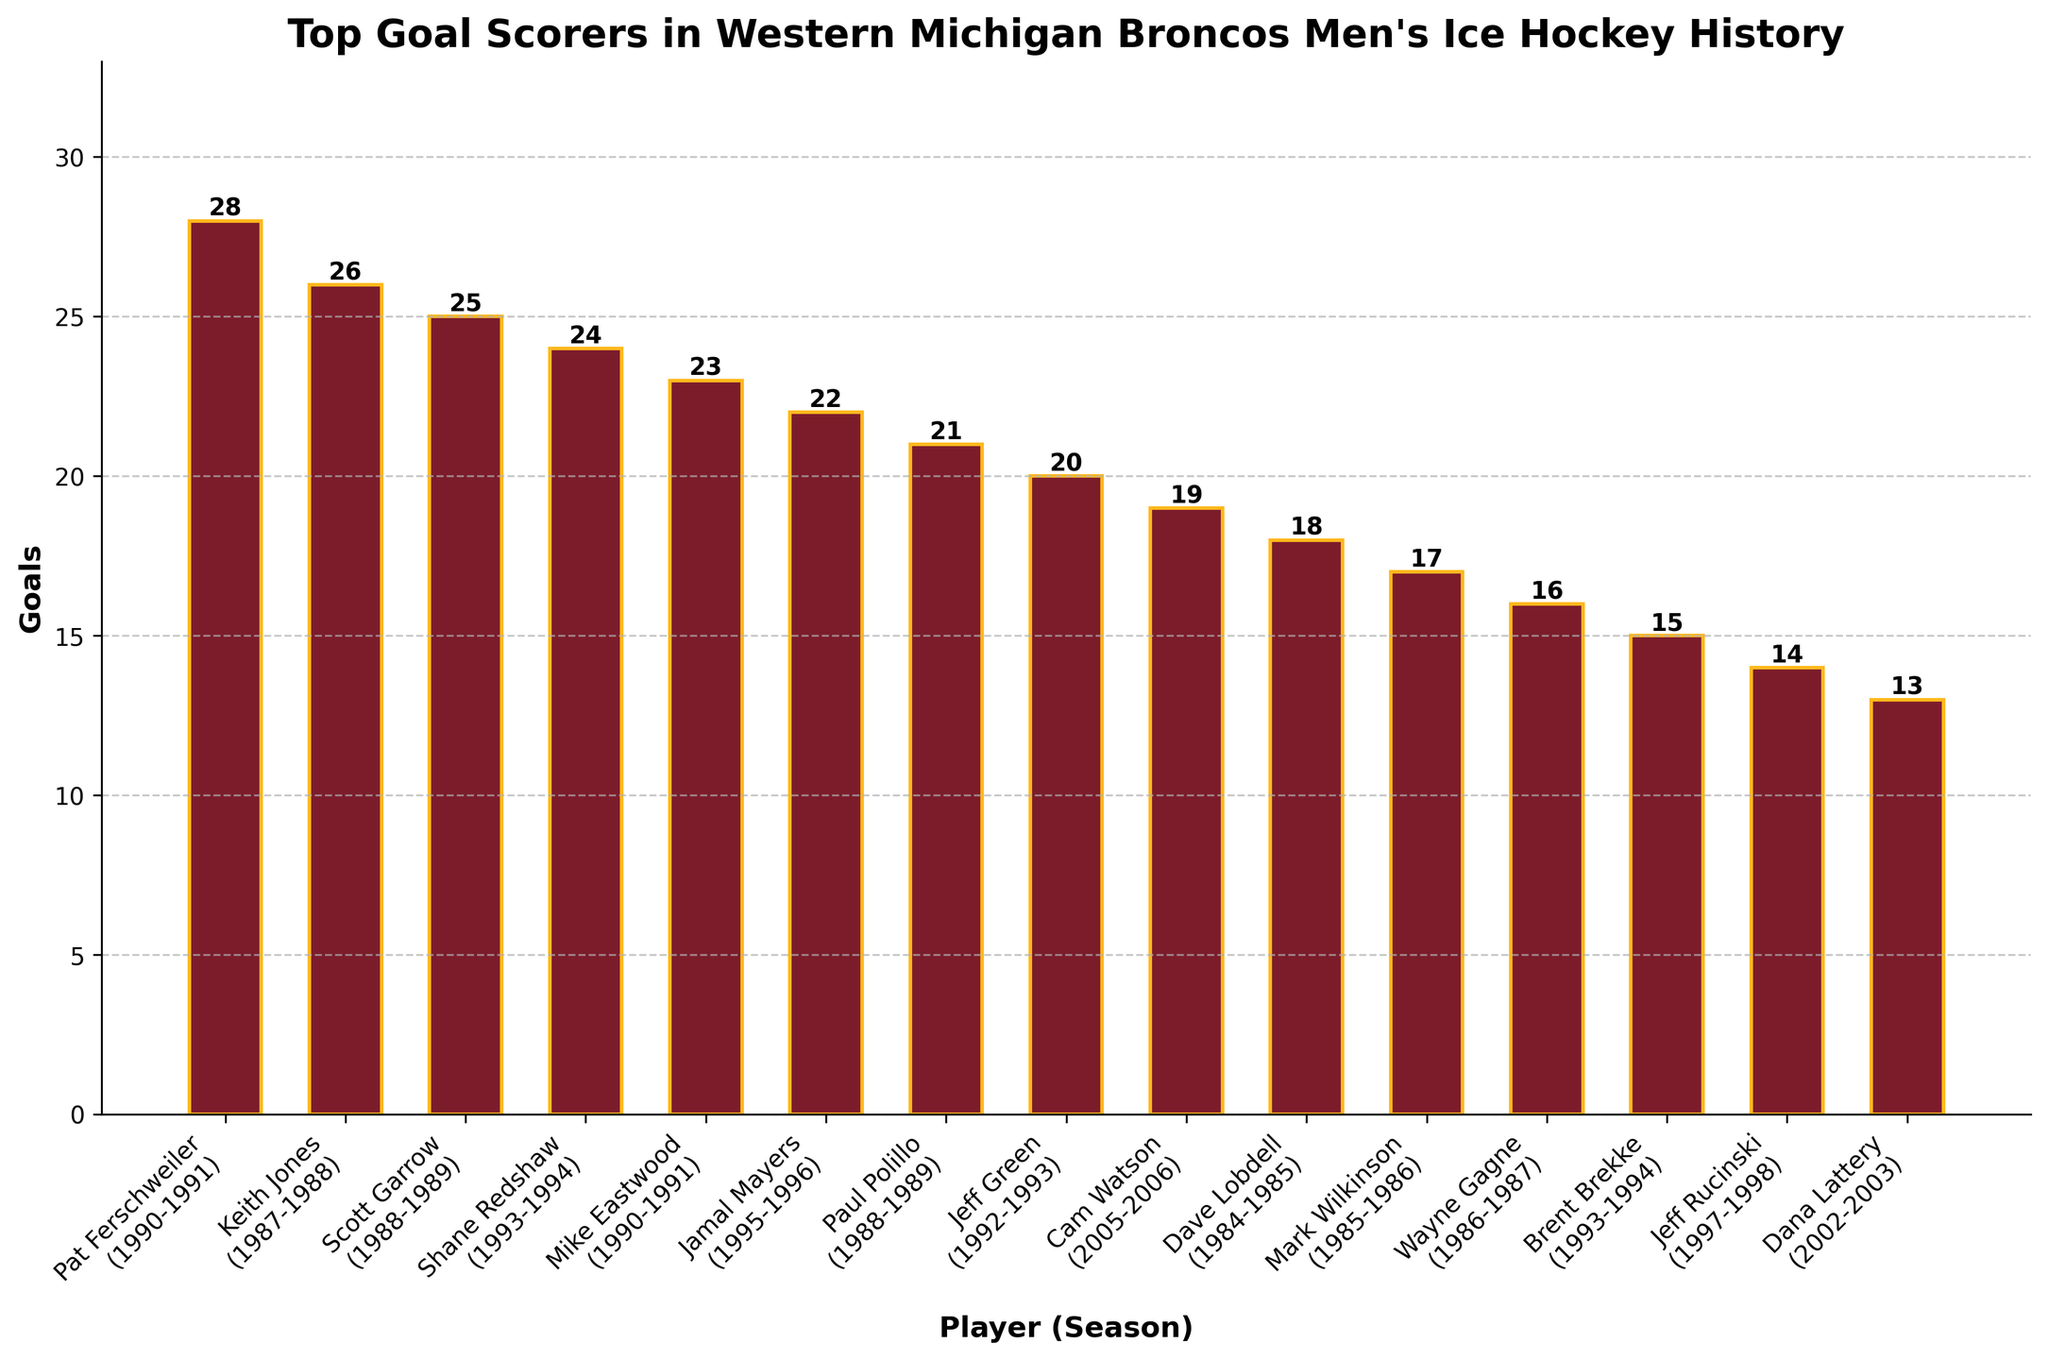Who is the top goal scorer for the Western Michigan Broncos in men's ice hockey history according to the chart? The bar representing Pat Ferschweiler is the tallest, with 28 goals.
Answer: Pat Ferschweiler In which season did Mike Eastwood score 23 goals? The label below Mike Eastwood's bar shows the season he scored 23 goals: 1990-1991.
Answer: 1990-1991 How many goals did Jeff Green and Cam Watson score in total? Jeff Green scored 20 goals, and Cam Watson scored 19 goals. Adding them together gives 20 + 19 = 39.
Answer: 39 Which players scored fewer than 20 goals in a season? The bars representing Dave Lobdell, Mark Wilkinson, Wayne Gagne, Brent Brekke, Jeff Rucinski, and Dana Lattery are shorter than 20 goals.
Answer: Dave Lobdell, Mark Wilkinson, Wayne Gagne, Brent Brekke, Jeff Rucinski, Dana Lattery Who scored more goals: Keith Jones in 1987-1988 or Scott Garrow in 1988-1989? The bar for Keith Jones in 1987-1988 has 26 goals, while the bar for Scott Garrow in 1988-1989 has 25 goals.
Answer: Keith Jones Which player scored 24 goals in a single season, and was it before or after the 1990s? The player with 24 goals is Shane Redshaw, and the corresponding season is 1993-1994, which is in the early 1990s.
Answer: Shane Redshaw, in the 1990s Who are the top three goal scorers, and how many goals did each score? The top three are Pat Ferschweiler with 28 goals, Keith Jones with 26 goals, and Scott Garrow with 25 goals.
Answer: Pat Ferschweiler (28), Keith Jones (26), Scott Garrow (25) What is the difference in goals between the player who scored the most and the player who scored the least? The player who scored the most, Pat Ferschweiler, scored 28 goals, and the player who scored the least, Dana Lattery, scored 13 goals. The difference is 28 - 13 = 15.
Answer: 15 Which players scored exactly 15 goals or less? The players are Brent Brekke (15), Jeff Rucinski (14), and Dana Lattery (13).
Answer: Brent Brekke, Jeff Rucinski, Dana Lattery What do the colors of the bars and the edges represent? The bars are filled with maroon, and the edges are gold, likely representing the school colors of Western Michigan University.
Answer: Maroon and gold represent school colors 